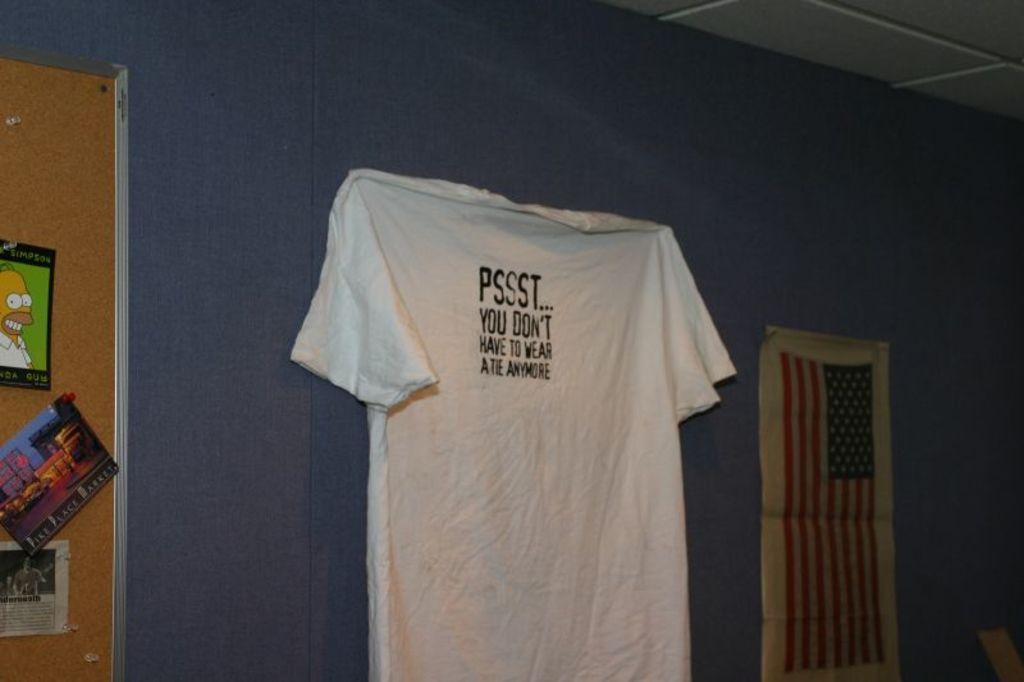Can you describe this image briefly? In this image we can see a shirt on the wall, it is in white color, here is the board, and some pictures on it, at above here is the roof. 